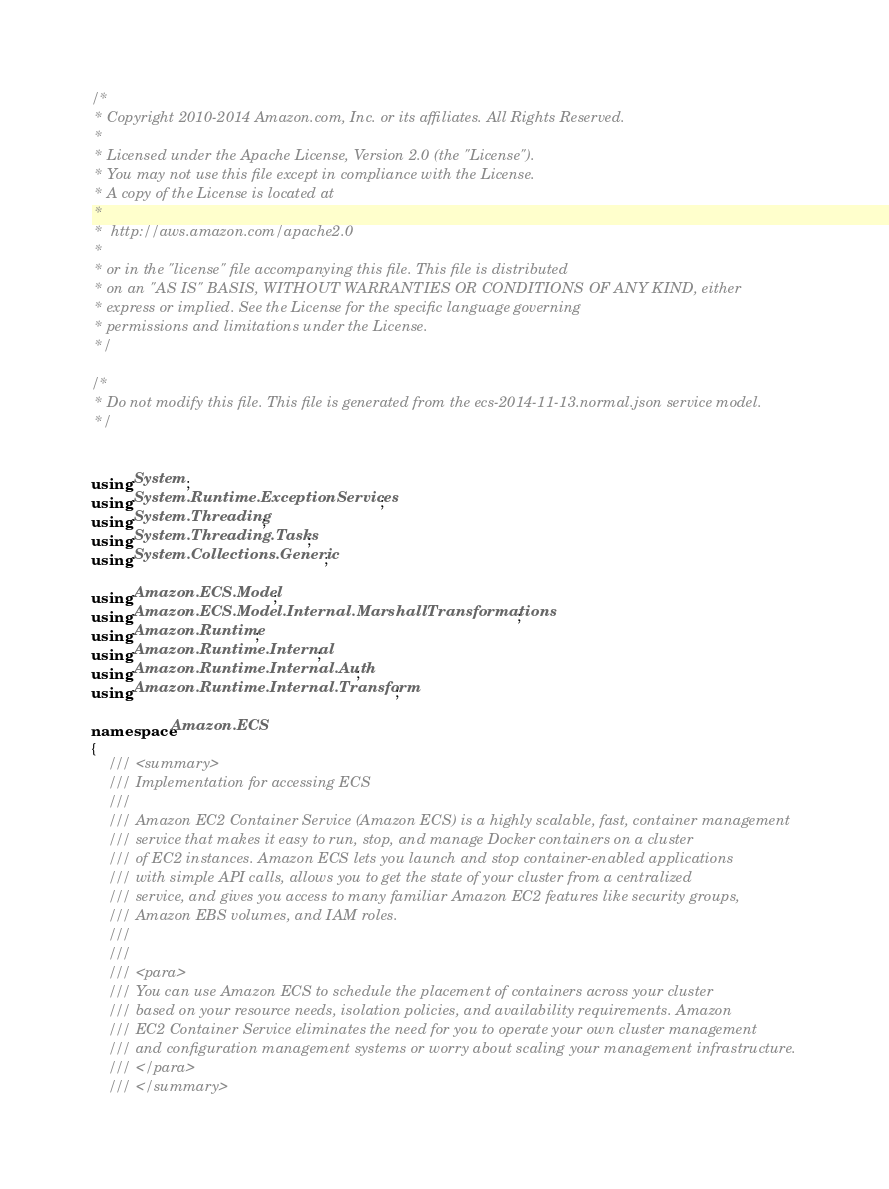Convert code to text. <code><loc_0><loc_0><loc_500><loc_500><_C#_>/*
 * Copyright 2010-2014 Amazon.com, Inc. or its affiliates. All Rights Reserved.
 * 
 * Licensed under the Apache License, Version 2.0 (the "License").
 * You may not use this file except in compliance with the License.
 * A copy of the License is located at
 * 
 *  http://aws.amazon.com/apache2.0
 * 
 * or in the "license" file accompanying this file. This file is distributed
 * on an "AS IS" BASIS, WITHOUT WARRANTIES OR CONDITIONS OF ANY KIND, either
 * express or implied. See the License for the specific language governing
 * permissions and limitations under the License.
 */

/*
 * Do not modify this file. This file is generated from the ecs-2014-11-13.normal.json service model.
 */


using System;
using System.Runtime.ExceptionServices;
using System.Threading;
using System.Threading.Tasks;
using System.Collections.Generic;

using Amazon.ECS.Model;
using Amazon.ECS.Model.Internal.MarshallTransformations;
using Amazon.Runtime;
using Amazon.Runtime.Internal;
using Amazon.Runtime.Internal.Auth;
using Amazon.Runtime.Internal.Transform;

namespace Amazon.ECS
{
    /// <summary>
    /// Implementation for accessing ECS
    ///
    /// Amazon EC2 Container Service (Amazon ECS) is a highly scalable, fast, container management
    /// service that makes it easy to run, stop, and manage Docker containers on a cluster
    /// of EC2 instances. Amazon ECS lets you launch and stop container-enabled applications
    /// with simple API calls, allows you to get the state of your cluster from a centralized
    /// service, and gives you access to many familiar Amazon EC2 features like security groups,
    /// Amazon EBS volumes, and IAM roles.
    /// 
    ///  
    /// <para>
    /// You can use Amazon ECS to schedule the placement of containers across your cluster
    /// based on your resource needs, isolation policies, and availability requirements. Amazon
    /// EC2 Container Service eliminates the need for you to operate your own cluster management
    /// and configuration management systems or worry about scaling your management infrastructure.
    /// </para>
    /// </summary></code> 